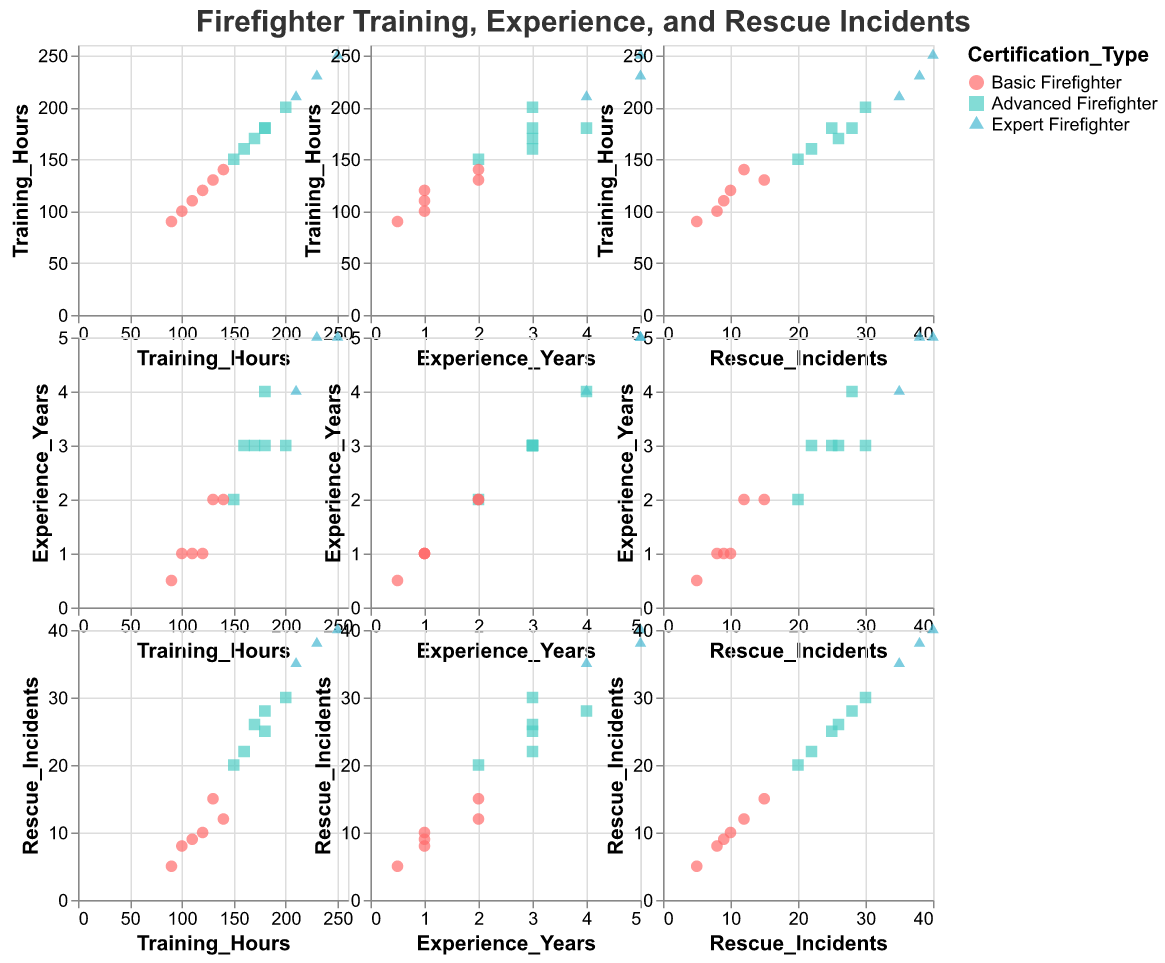What is the title of the figure? The figure’s title is prominently displayed at the top. The title reads "Firefighter Training, Experience, and Rescue Incidents".
Answer: Firefighter Training, Experience, and Rescue Incidents What are the different types of firefighter certifications represented in the plot? The plot uses color and shape to differentiate between certification types. The legend shows that the certifications are Basic Firefighter (circle, red), Advanced Firefighter (square, green), and Expert Firefighter (triangle, blue).
Answer: Basic Firefighter, Advanced Firefighter, Expert Firefighter Which certification type has the highest training hours? By looking at the scatter plot matrix, we can see that the certification with the highest training hours is represented by the blue triangles, which correspond to the "Expert Firefighter" category.
Answer: Expert Firefighter Is there a positive correlation between Training Hours and Experience Years? Examining the scatter plot that compares Training Hours and Experience Years, we can observe a general upward trend, indicating that as training hours increase, so do experience years, suggesting a positive correlation.
Answer: Yes How many data points represent "Advanced Firefighters" in the matrix? Looking at the number of green squares (which represent Advanced Firefighters) in the scatter plots will help us count them. There are 6 green squares.
Answer: 6 What is the range of experience years for "Basic Firefighters"? Filtering the points that are red circles (Basic Firefighters) in the scatter plot of Experience Years, we see that the experience ranges from 0.5 to 2 years.
Answer: 0.5 to 2 years Among those with 3 years of experience, which certification type generally has more rescue incidents? By isolating data points with 3 years of experience and comparing the corresponding certification types, we find Advanced Firefighters (green squares) generally have more rescue incidents.
Answer: Advanced Firefighters What is the difference in rescue incidents between the firefighter with the highest and the lowest training hours? The firefighter with the highest training hours (250) has 40 rescue incidents. The one with the lowest training hours (90) has 5 rescue incidents. The difference is calculated as 40 - 5 = 35.
Answer: 35 Which group of firefighters has the narrowest spread in Training Hours? Comparing the spread (range) of training hours across different certification types: Basic (90-140), Advanced (150-200), Expert (210-250). "Basic Firefighters" have the narrowest spread.
Answer: Basic Firefighters 